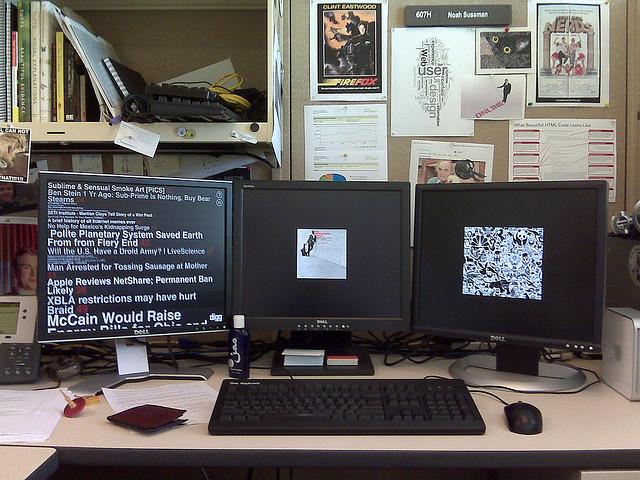Is the writing on the screen English?
Give a very brief answer. Yes. How many screens?
Answer briefly. 3. What color is the keyboard?
Give a very brief answer. Black. 